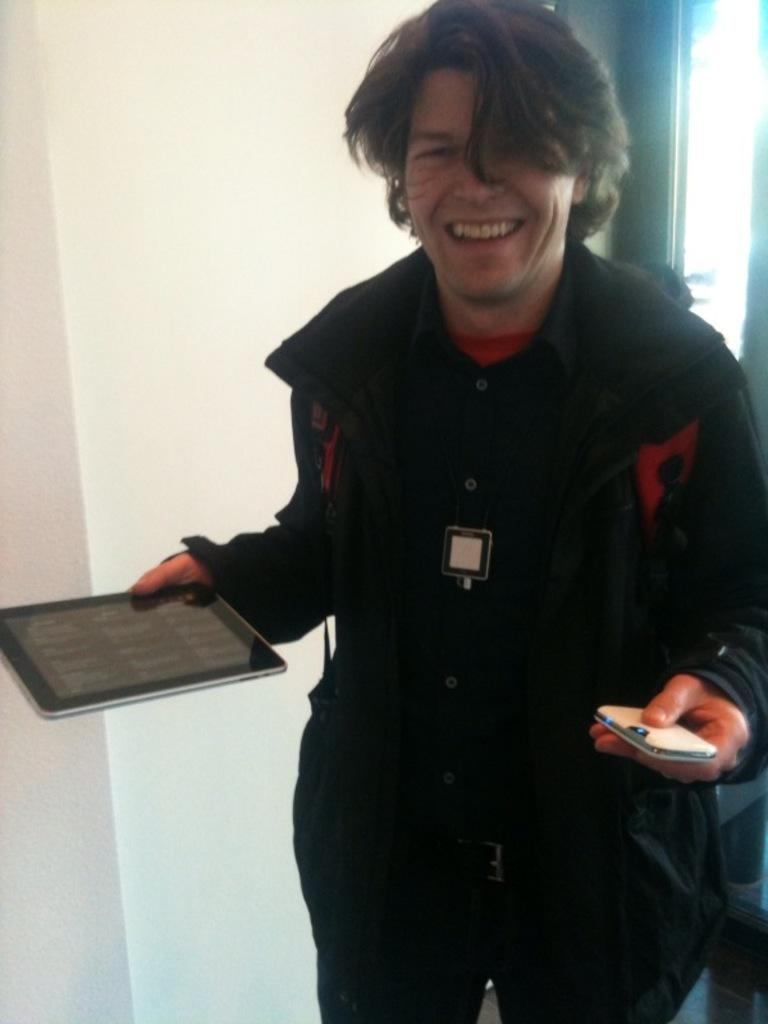What is the main subject of the image? There is a person in the image. What is the person doing in the image? The person is standing and smiling. What is the person holding in the image? The person is holding electronic devices. What can be seen behind the person in the image? There is a wall behind the person. Is the person using an umbrella to shield themselves from the heat in the image? There is no umbrella present in the image, and no indication of heat or the need for shielding. 